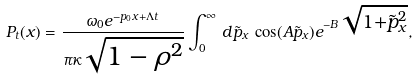Convert formula to latex. <formula><loc_0><loc_0><loc_500><loc_500>P _ { t } ( x ) = \frac { \omega _ { 0 } e ^ { - p _ { 0 } x + \Lambda t } } { \pi \kappa \sqrt { 1 - \rho ^ { 2 } } } \int _ { 0 } ^ { \infty } \, d \tilde { p } _ { x } \, \cos ( A \tilde { p } _ { x } ) e ^ { - B \sqrt { 1 + \tilde { p } _ { x } ^ { 2 } } } ,</formula> 